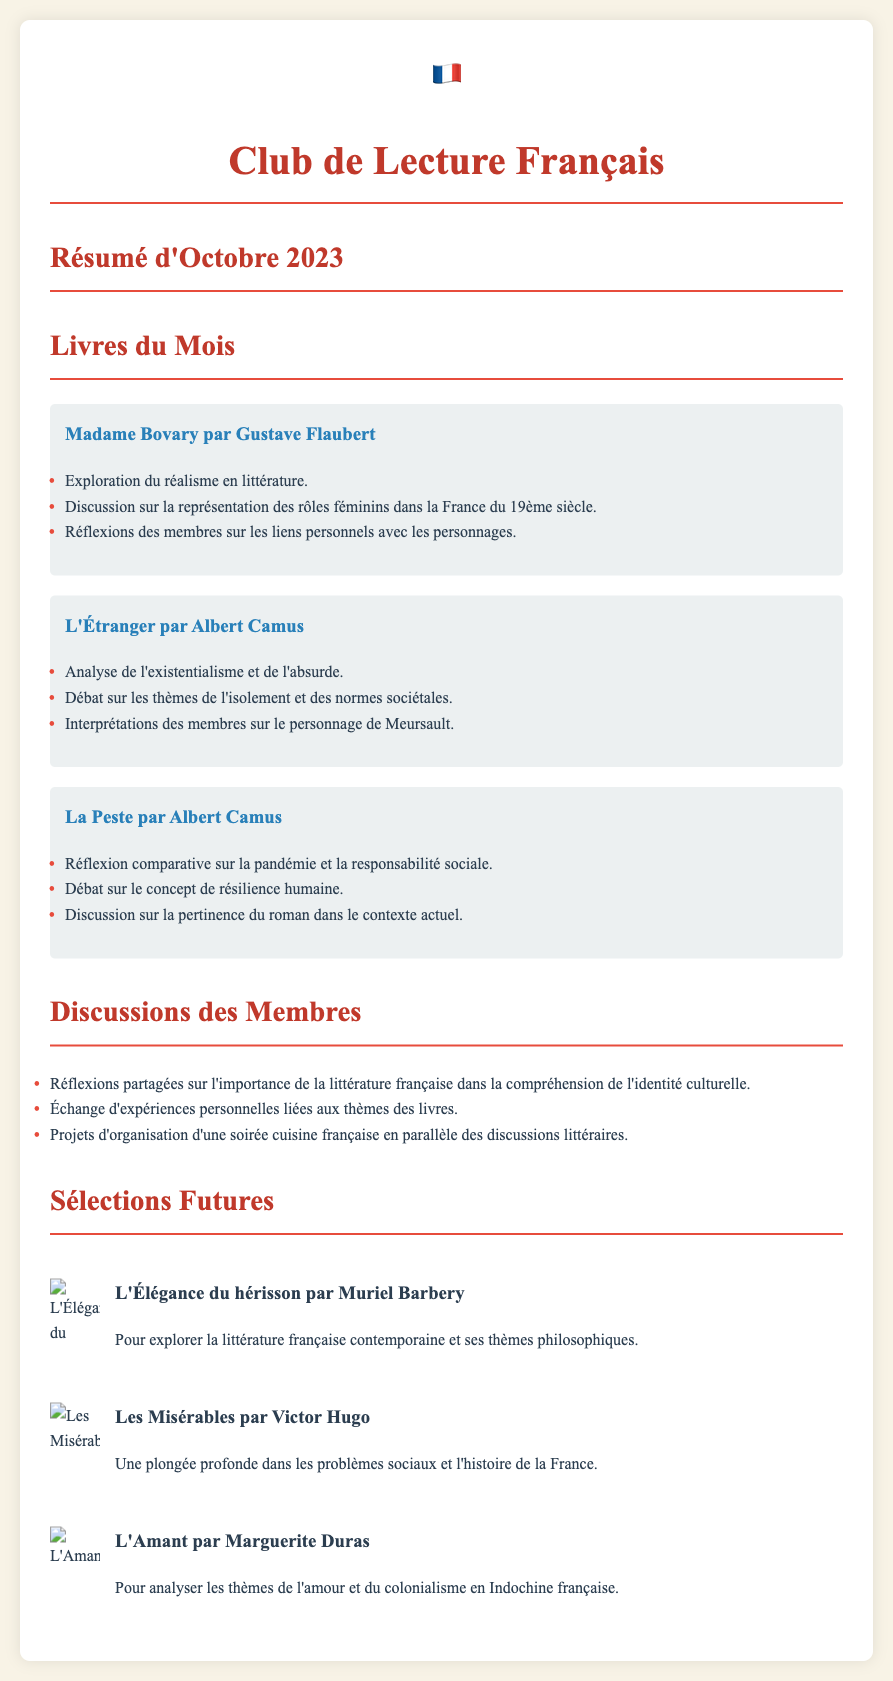What were the books discussed in October 2023? The books discussed are listed under "Livres du Mois" in the document, including titles like "Madame Bovary" and "L'Étranger."
Answer: "Madame Bovary, L'Étranger, La Peste" Who is the author of "L'Étranger"? The document clearly states that "L'Étranger" was written by Albert Camus.
Answer: Albert Camus What was a key theme discussed regarding "La Peste"? The key themes discussed include pandemic and social responsibility as listed in the document.
Answer: Pandémie et responsabilité sociale How many future book selections are mentioned? The document lists three future book selections in the "Sélections Futures" section.
Answer: 3 Which future book focuses on colonialism? The title of the future book that focuses on colonialism is highlighted in the "Sélections Futures."
Answer: L'Amant What did members discuss regarding the importance of French literature? Members shared reflections regarding its role in understanding cultural identity.
Answer: Importance de l'identité culturelle What type of event do members plan to organize alongside the discussions? The document mentions plans for a culinary event linked to the book discussions.
Answer: Soirée cuisine française What genre is "Les Misérables"? The document indicates that "Les Misérables" explores social problems and historical themes.
Answer: Problèmes sociaux et histoire 